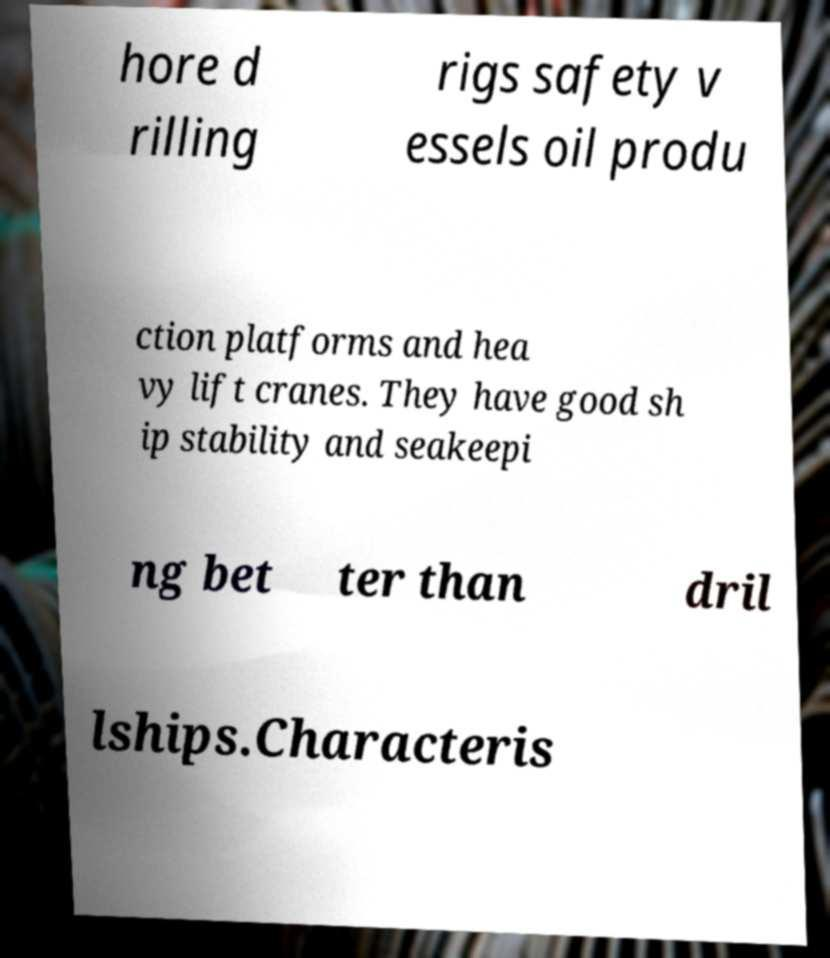Can you accurately transcribe the text from the provided image for me? hore d rilling rigs safety v essels oil produ ction platforms and hea vy lift cranes. They have good sh ip stability and seakeepi ng bet ter than dril lships.Characteris 